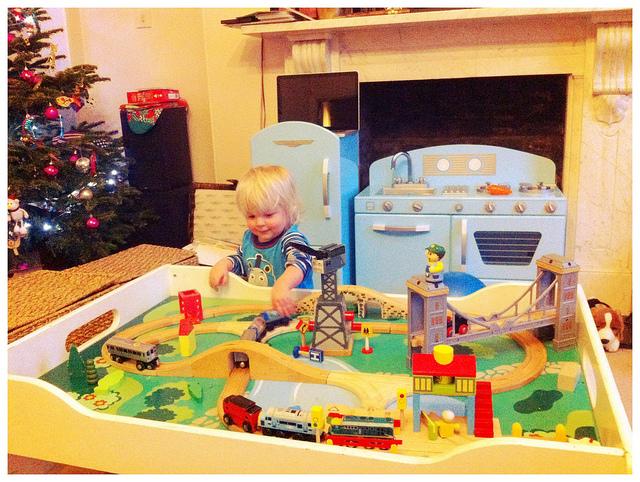Was this taken in August?
Write a very short answer. No. What time of year is it?
Give a very brief answer. Christmas. What color is the stove?
Short answer required. Blue. 